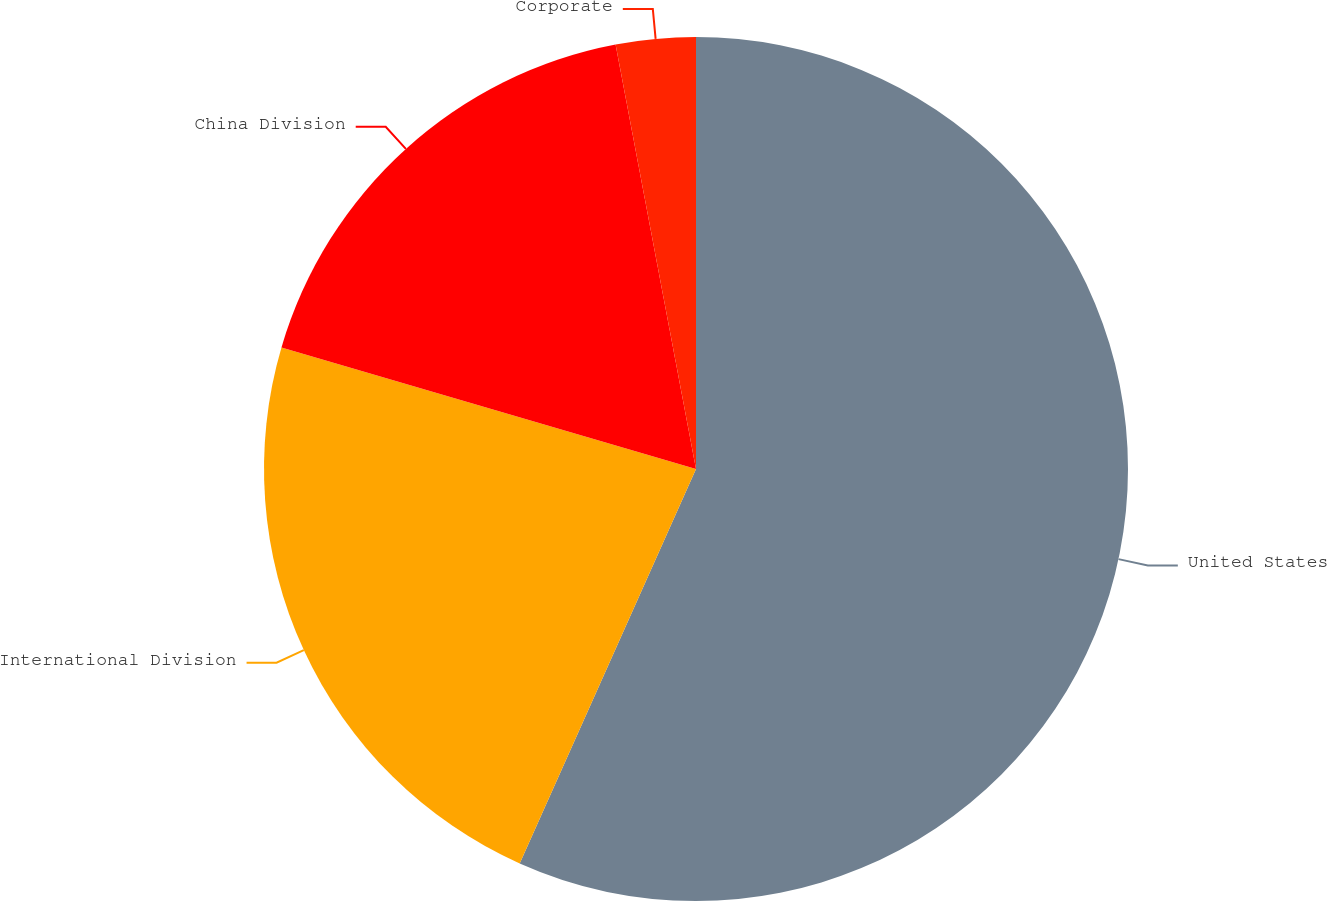Convert chart. <chart><loc_0><loc_0><loc_500><loc_500><pie_chart><fcel>United States<fcel>International Division<fcel>China Division<fcel>Corporate<nl><fcel>56.69%<fcel>22.85%<fcel>17.48%<fcel>2.98%<nl></chart> 